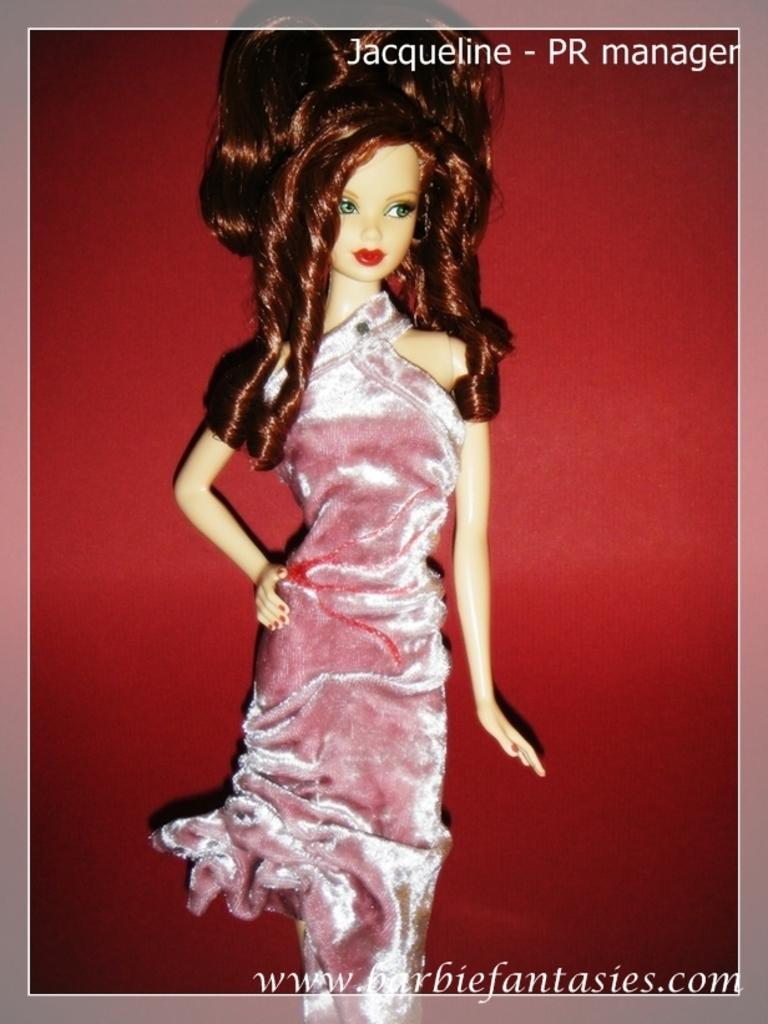Please provide a concise description of this image. There is a doll with a velvet cloth. There are watermarks on the right corners. In the background there is a red wall. 